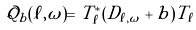Convert formula to latex. <formula><loc_0><loc_0><loc_500><loc_500>\mathcal { Q } _ { b } ( \ell , \omega ) = T _ { \ell } ^ { * } ( D _ { \ell , \omega } + b ) T _ { \ell }</formula> 